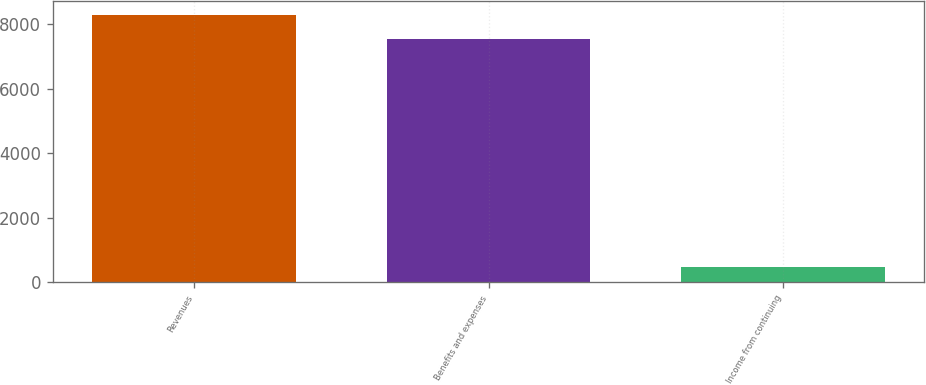Convert chart to OTSL. <chart><loc_0><loc_0><loc_500><loc_500><bar_chart><fcel>Revenues<fcel>Benefits and expenses<fcel>Income from continuing<nl><fcel>8298.4<fcel>7544<fcel>482<nl></chart> 